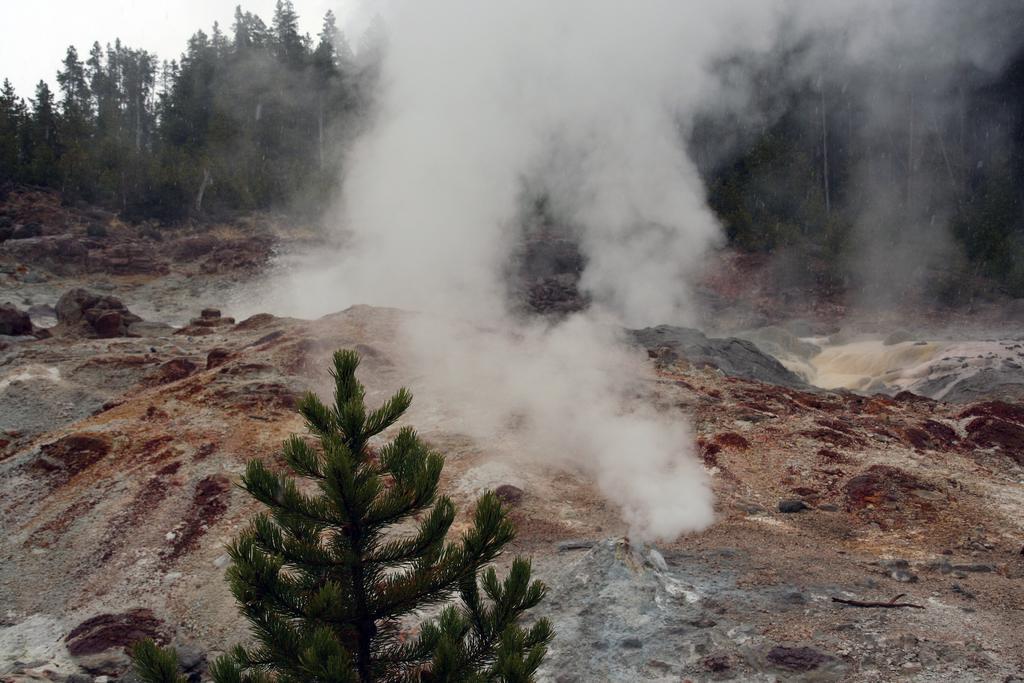In one or two sentences, can you explain what this image depicts? In this picture I can observe smoke. In the bottom of the picture I can observe small tree. In the background there are trees and sky. 